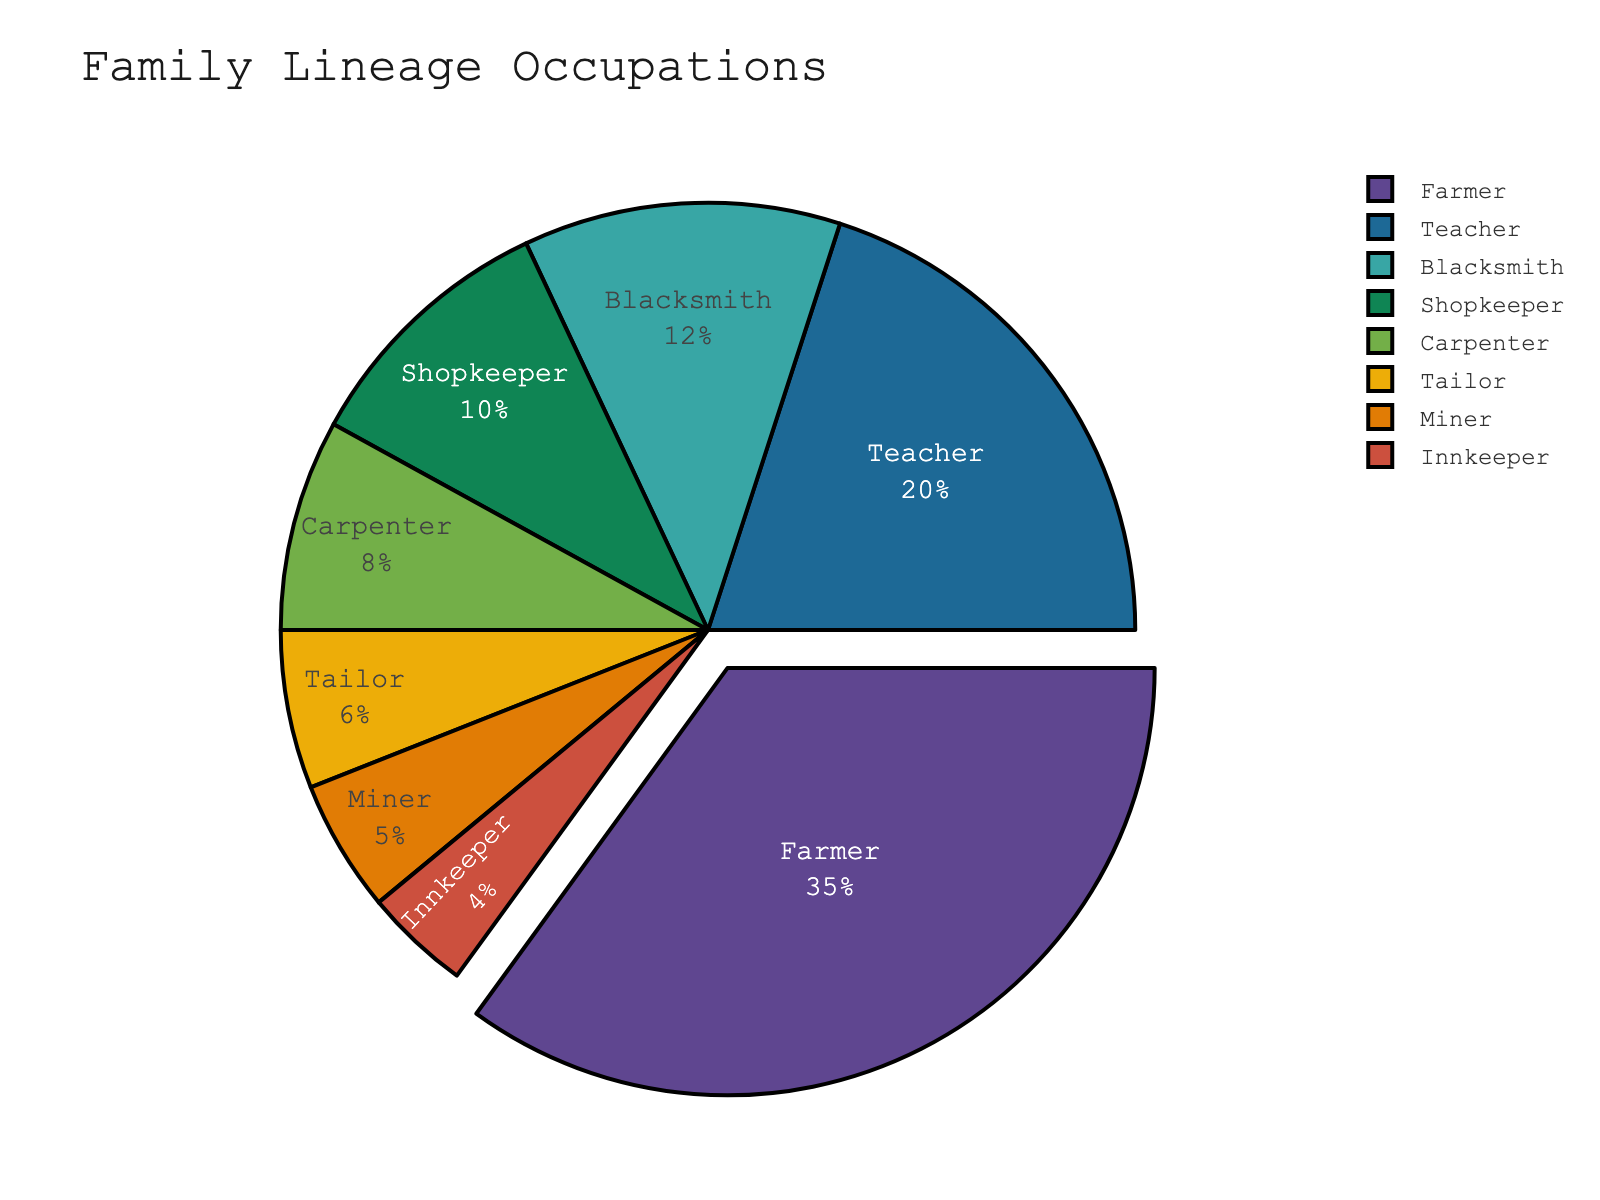What's the most common occupation? The largest section of the pie chart represents the occupation with the highest percentage. By visually inspecting the sections, the "Farmer" section is the largest, indicating it's the most common occupation.
Answer: Farmer Which two occupations combined make up over 50%? Adding the percentages of different occupations, we find that "Farmer" (35%) and "Teacher" (20%) together sum up to 55%, which is over 50%.
Answer: Farmer and Teacher How much larger is the percentage of Farmers compared to Miners? Subtract the percentage of Miners (5%) from Farmers (35%) to find the difference: 35% - 5% = 30%.
Answer: 30% Which occupation takes up the smallest portion of the pie chart? By identifying the smallest section visually, we see that the "Innkeeper" section is the smallest at 4%.
Answer: Innkeeper How many occupations have a percentage greater than or equal to 10%? By examining the chart, we see "Farmer" (35%), "Teacher" (20%), "Blacksmith" (12%), and "Shopkeeper" (10%) all meet or exceed 10%.
Answer: Four If you combine the percentages of all craft-related occupations (Blacksmith, Carpenter, Tailor), what is the total? Adding "Blacksmith" (12%), "Carpenter" (8%), and "Tailor" (6%) gives: 12% + 8% + 6% = 26%.
Answer: 26% What is the second least common occupation? After identifying the smallest segment (Innkeeper, 4%), the second smallest is "Miner" at 5%.
Answer: Miner What occupations make up the top three percentages? The largest sections represent "Farmer" (35%), "Teacher" (20%), and "Blacksmith" (12%).
Answer: Farmer, Teacher, and Blacksmith Which occupation has a percentage less than double that of a Tailor? Tailor has 6%, double this is 12%. The "Blacksmith" at 12% is not less, so the next lowest but within range is "Shopkeeper" at 10%.
Answer: Shopkeeper 